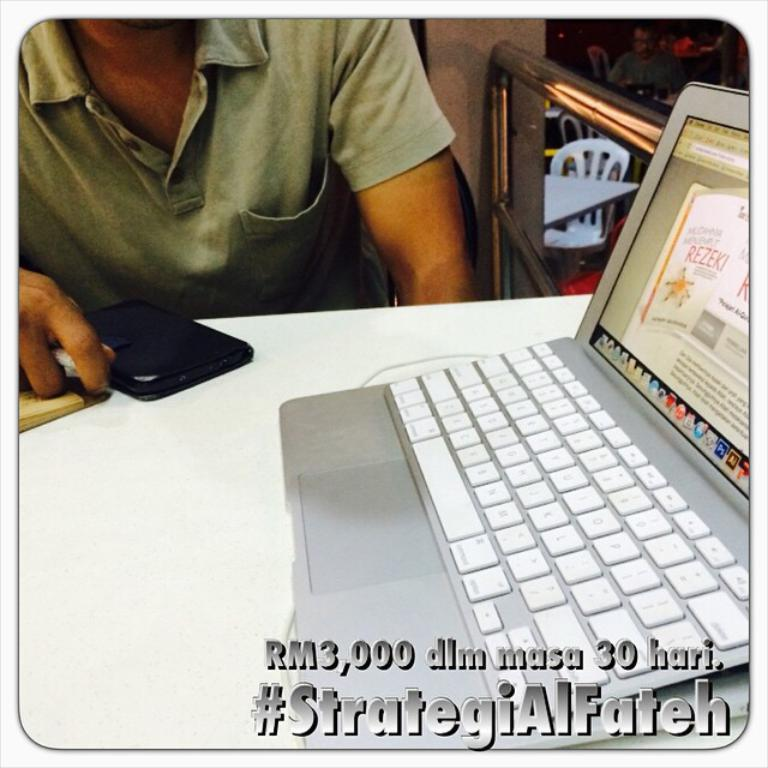<image>
Present a compact description of the photo's key features. Person using a silver Macbook with a screen that says "Rezeki". 